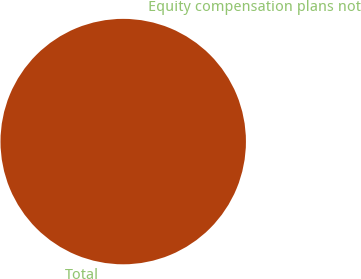Convert chart to OTSL. <chart><loc_0><loc_0><loc_500><loc_500><pie_chart><fcel>Equity compensation plans not<fcel>Total<nl><fcel>0.0%<fcel>100.0%<nl></chart> 